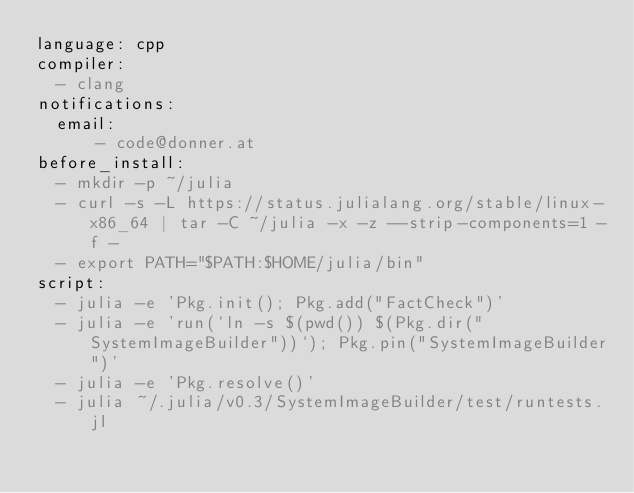<code> <loc_0><loc_0><loc_500><loc_500><_YAML_>language: cpp
compiler:
  - clang
notifications:
  email: 
      - code@donner.at
before_install:
  - mkdir -p ~/julia
  - curl -s -L https://status.julialang.org/stable/linux-x86_64 | tar -C ~/julia -x -z --strip-components=1 -f -
  - export PATH="$PATH:$HOME/julia/bin" 
script:
  - julia -e 'Pkg.init(); Pkg.add("FactCheck")'
  - julia -e 'run(`ln -s $(pwd()) $(Pkg.dir("SystemImageBuilder"))`); Pkg.pin("SystemImageBuilder")'
  - julia -e 'Pkg.resolve()'
  - julia ~/.julia/v0.3/SystemImageBuilder/test/runtests.jl
</code> 